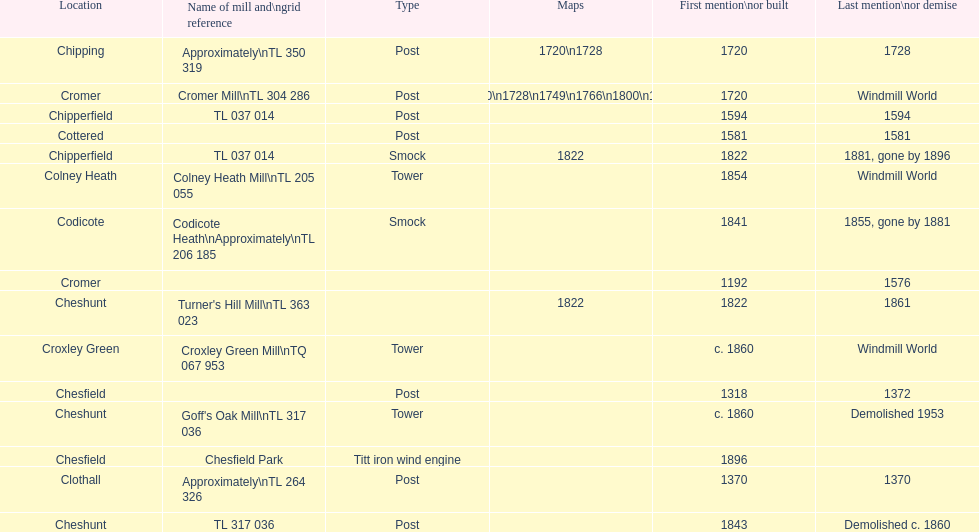What is the name of the only "c" mill located in colney health? Colney Heath Mill. 